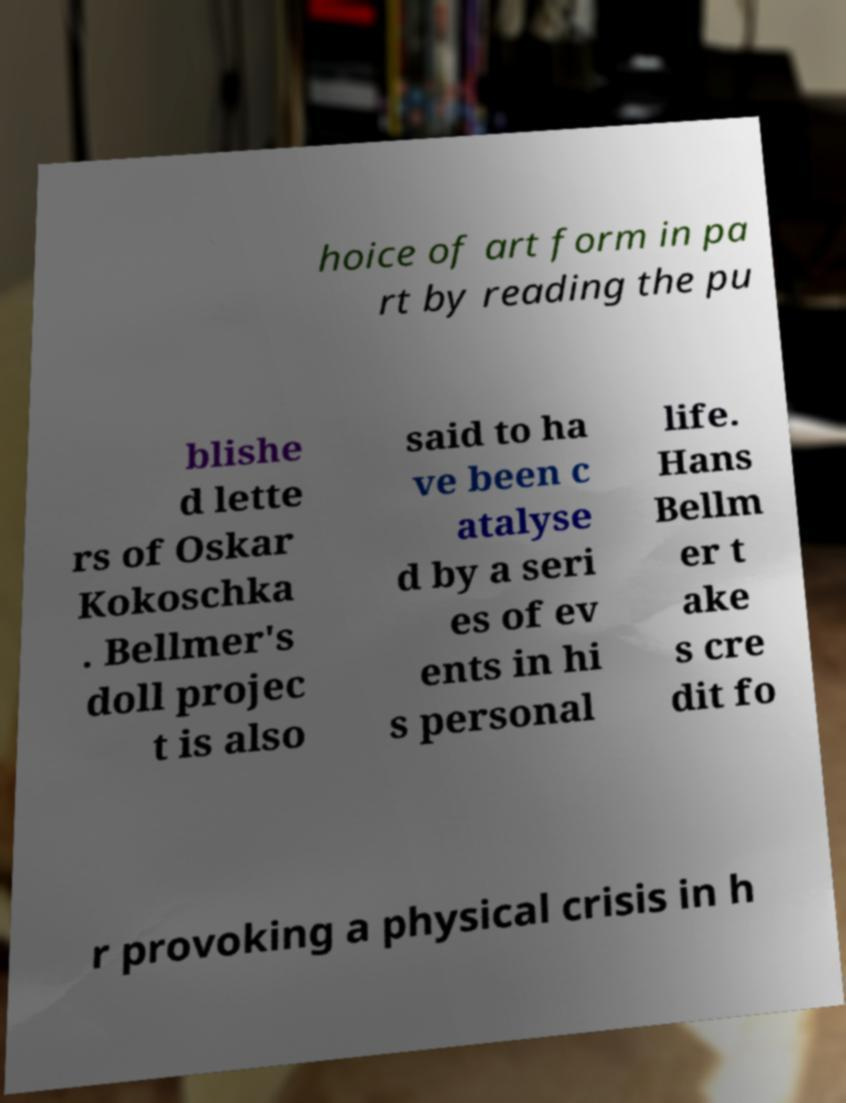I need the written content from this picture converted into text. Can you do that? hoice of art form in pa rt by reading the pu blishe d lette rs of Oskar Kokoschka . Bellmer's doll projec t is also said to ha ve been c atalyse d by a seri es of ev ents in hi s personal life. Hans Bellm er t ake s cre dit fo r provoking a physical crisis in h 